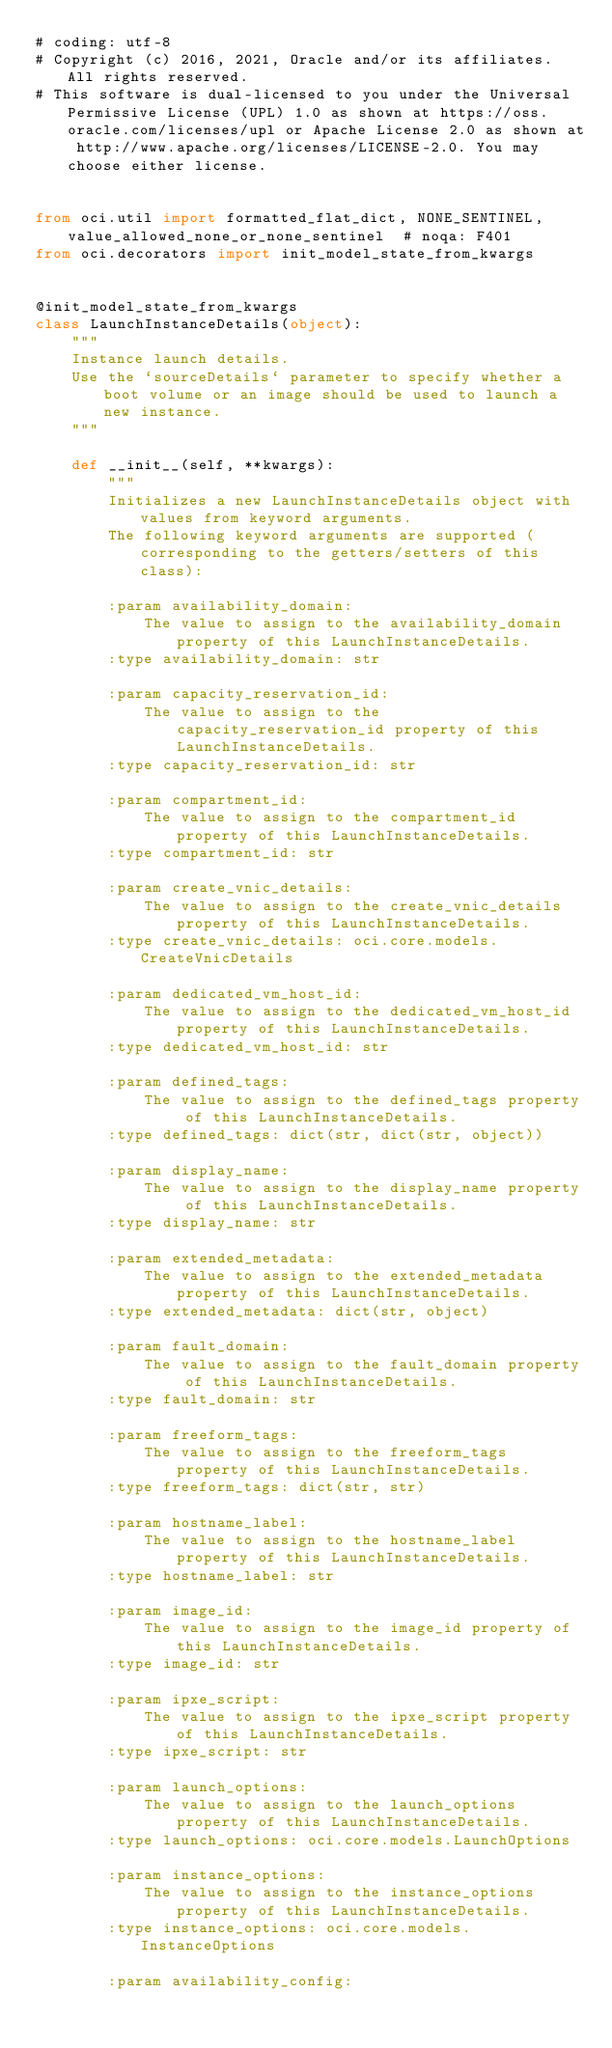Convert code to text. <code><loc_0><loc_0><loc_500><loc_500><_Python_># coding: utf-8
# Copyright (c) 2016, 2021, Oracle and/or its affiliates.  All rights reserved.
# This software is dual-licensed to you under the Universal Permissive License (UPL) 1.0 as shown at https://oss.oracle.com/licenses/upl or Apache License 2.0 as shown at http://www.apache.org/licenses/LICENSE-2.0. You may choose either license.


from oci.util import formatted_flat_dict, NONE_SENTINEL, value_allowed_none_or_none_sentinel  # noqa: F401
from oci.decorators import init_model_state_from_kwargs


@init_model_state_from_kwargs
class LaunchInstanceDetails(object):
    """
    Instance launch details.
    Use the `sourceDetails` parameter to specify whether a boot volume or an image should be used to launch a new instance.
    """

    def __init__(self, **kwargs):
        """
        Initializes a new LaunchInstanceDetails object with values from keyword arguments.
        The following keyword arguments are supported (corresponding to the getters/setters of this class):

        :param availability_domain:
            The value to assign to the availability_domain property of this LaunchInstanceDetails.
        :type availability_domain: str

        :param capacity_reservation_id:
            The value to assign to the capacity_reservation_id property of this LaunchInstanceDetails.
        :type capacity_reservation_id: str

        :param compartment_id:
            The value to assign to the compartment_id property of this LaunchInstanceDetails.
        :type compartment_id: str

        :param create_vnic_details:
            The value to assign to the create_vnic_details property of this LaunchInstanceDetails.
        :type create_vnic_details: oci.core.models.CreateVnicDetails

        :param dedicated_vm_host_id:
            The value to assign to the dedicated_vm_host_id property of this LaunchInstanceDetails.
        :type dedicated_vm_host_id: str

        :param defined_tags:
            The value to assign to the defined_tags property of this LaunchInstanceDetails.
        :type defined_tags: dict(str, dict(str, object))

        :param display_name:
            The value to assign to the display_name property of this LaunchInstanceDetails.
        :type display_name: str

        :param extended_metadata:
            The value to assign to the extended_metadata property of this LaunchInstanceDetails.
        :type extended_metadata: dict(str, object)

        :param fault_domain:
            The value to assign to the fault_domain property of this LaunchInstanceDetails.
        :type fault_domain: str

        :param freeform_tags:
            The value to assign to the freeform_tags property of this LaunchInstanceDetails.
        :type freeform_tags: dict(str, str)

        :param hostname_label:
            The value to assign to the hostname_label property of this LaunchInstanceDetails.
        :type hostname_label: str

        :param image_id:
            The value to assign to the image_id property of this LaunchInstanceDetails.
        :type image_id: str

        :param ipxe_script:
            The value to assign to the ipxe_script property of this LaunchInstanceDetails.
        :type ipxe_script: str

        :param launch_options:
            The value to assign to the launch_options property of this LaunchInstanceDetails.
        :type launch_options: oci.core.models.LaunchOptions

        :param instance_options:
            The value to assign to the instance_options property of this LaunchInstanceDetails.
        :type instance_options: oci.core.models.InstanceOptions

        :param availability_config:</code> 